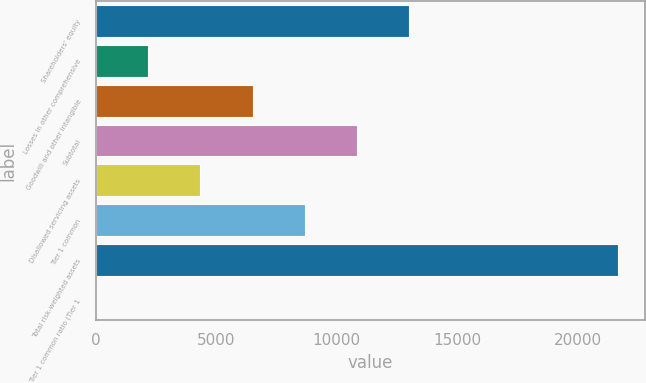<chart> <loc_0><loc_0><loc_500><loc_500><bar_chart><fcel>Shareholders' equity<fcel>Losses in other comprehensive<fcel>Goodwill and other intangible<fcel>Subtotal<fcel>Disallowed servicing assets<fcel>Tier 1 common<fcel>Total risk-weighted assets<fcel>Tier 1 common ratio (Tier 1<nl><fcel>13004.6<fcel>2175.27<fcel>6507.01<fcel>10838.8<fcel>4341.14<fcel>8672.88<fcel>21668.1<fcel>9.4<nl></chart> 